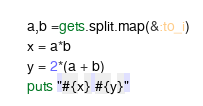<code> <loc_0><loc_0><loc_500><loc_500><_Ruby_>a,b =gets.split.map(&:to_i)
x = a*b
y = 2*(a + b)
puts "#{x} #{y}"</code> 